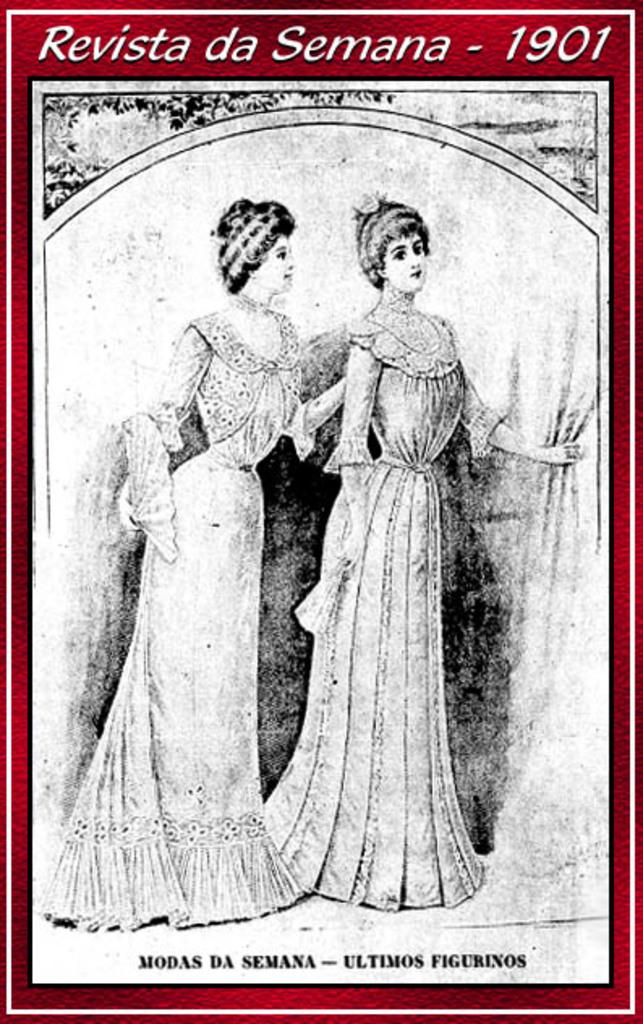How many people are present in the image? There are two ladies standing in the image. What can be seen at the top of the image? There is a tree at the top of the image. What is present in the background of the image? There is a curtain and text visible in the background of the image. How many beds can be seen in the image? There are no beds present in the image. What type of milk is being served in the image? There is no milk present in the image. 